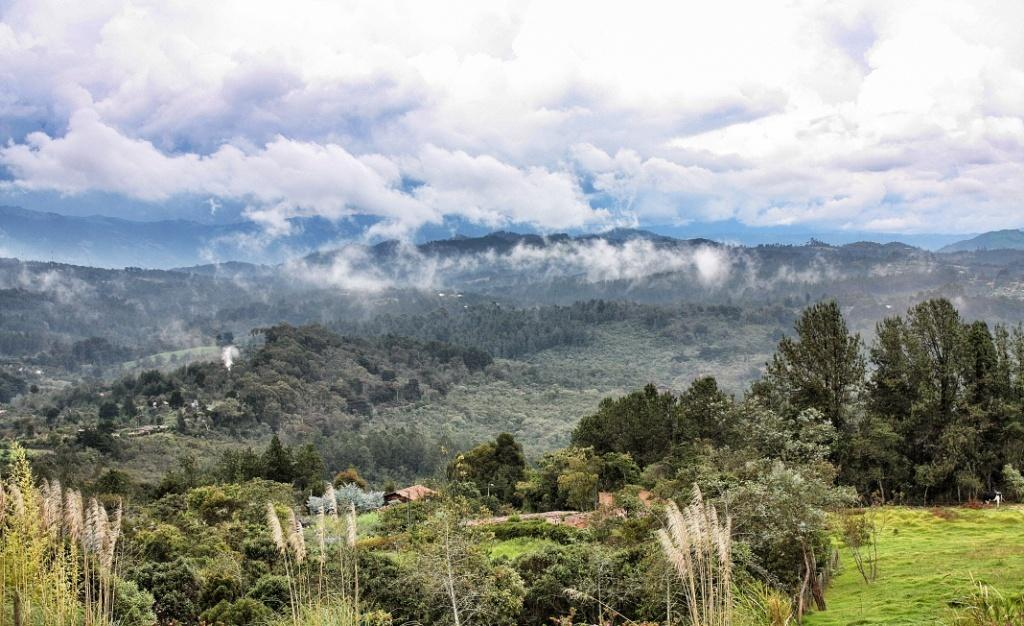What type of vegetation can be seen in the image? There are trees, plants, and grass in the image. What type of natural landform is visible in the image? There are mountains in the image. What is visible in the background of the image? The sky is visible in the image, and there are clouds in the sky. Where is the zoo located in the image? There is no zoo present in the image. What type of animal is wearing a mitten in the image? There are no animals or mittens present in the image. 